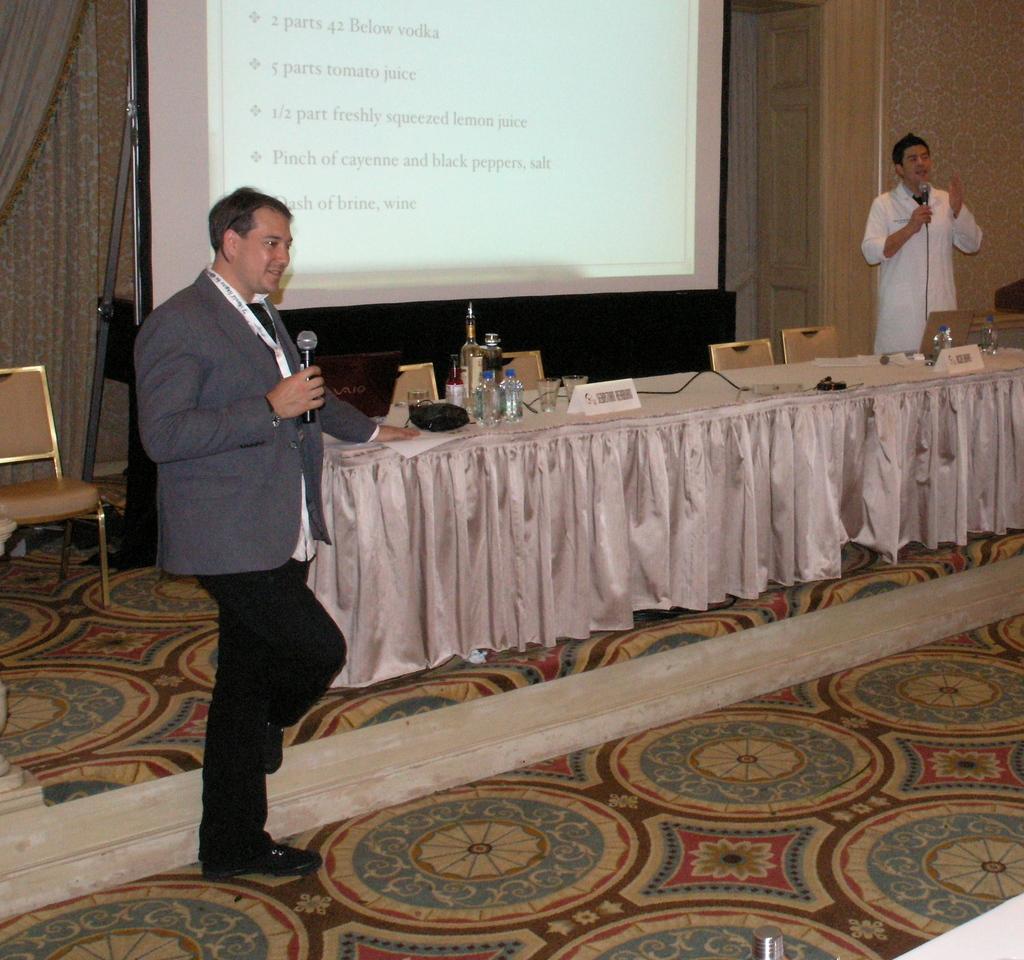How would you summarize this image in a sentence or two? A person is holding a mic and standing. Also in the corner another person wearing white coat is holding mic and standing. There is a table. On the table there is a cloth, nameplate , glasses and some other items. Also there are chairs. In the background there is a wall and a screen. Also on the floor there are carpets. 